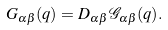<formula> <loc_0><loc_0><loc_500><loc_500>G _ { \alpha \beta } ( q ) = D _ { \alpha \beta } \, { \mathcal { G } } _ { \alpha \beta } ( q ) .</formula> 